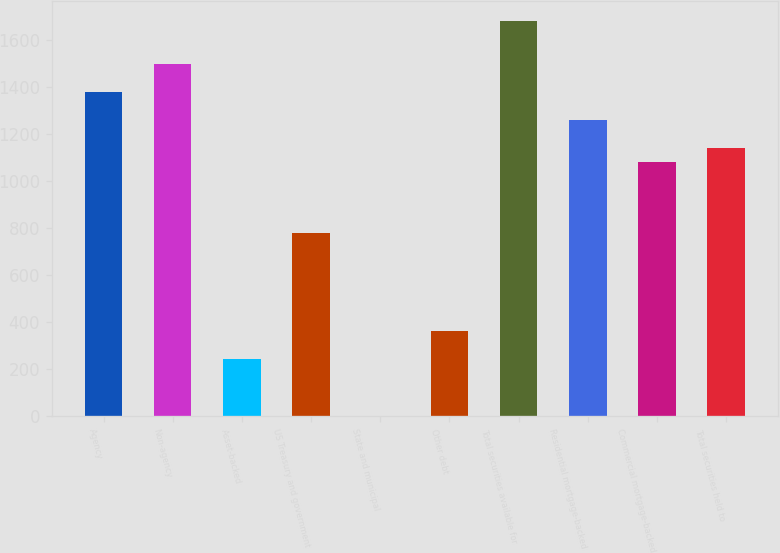<chart> <loc_0><loc_0><loc_500><loc_500><bar_chart><fcel>Agency<fcel>Non-agency<fcel>Asset-backed<fcel>US Treasury and government<fcel>State and municipal<fcel>Other debt<fcel>Total securities available for<fcel>Residential mortgage-backed<fcel>Commercial mortgage-backed<fcel>Total securities held to<nl><fcel>1381<fcel>1501<fcel>241<fcel>781<fcel>1<fcel>361<fcel>1681<fcel>1261<fcel>1081<fcel>1141<nl></chart> 